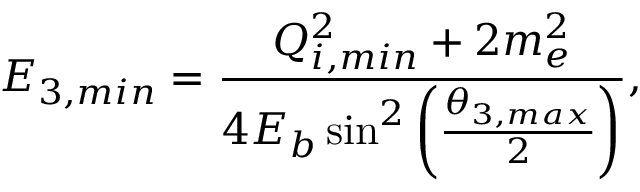Convert formula to latex. <formula><loc_0><loc_0><loc_500><loc_500>E _ { 3 , { \min } } = \frac { Q _ { i , { \min } } ^ { 2 } + 2 m _ { e } ^ { 2 } } { 4 E _ { b } \sin ^ { 2 } \left ( \frac { \theta _ { 3 , { \max } } } { 2 } \right ) } ,</formula> 